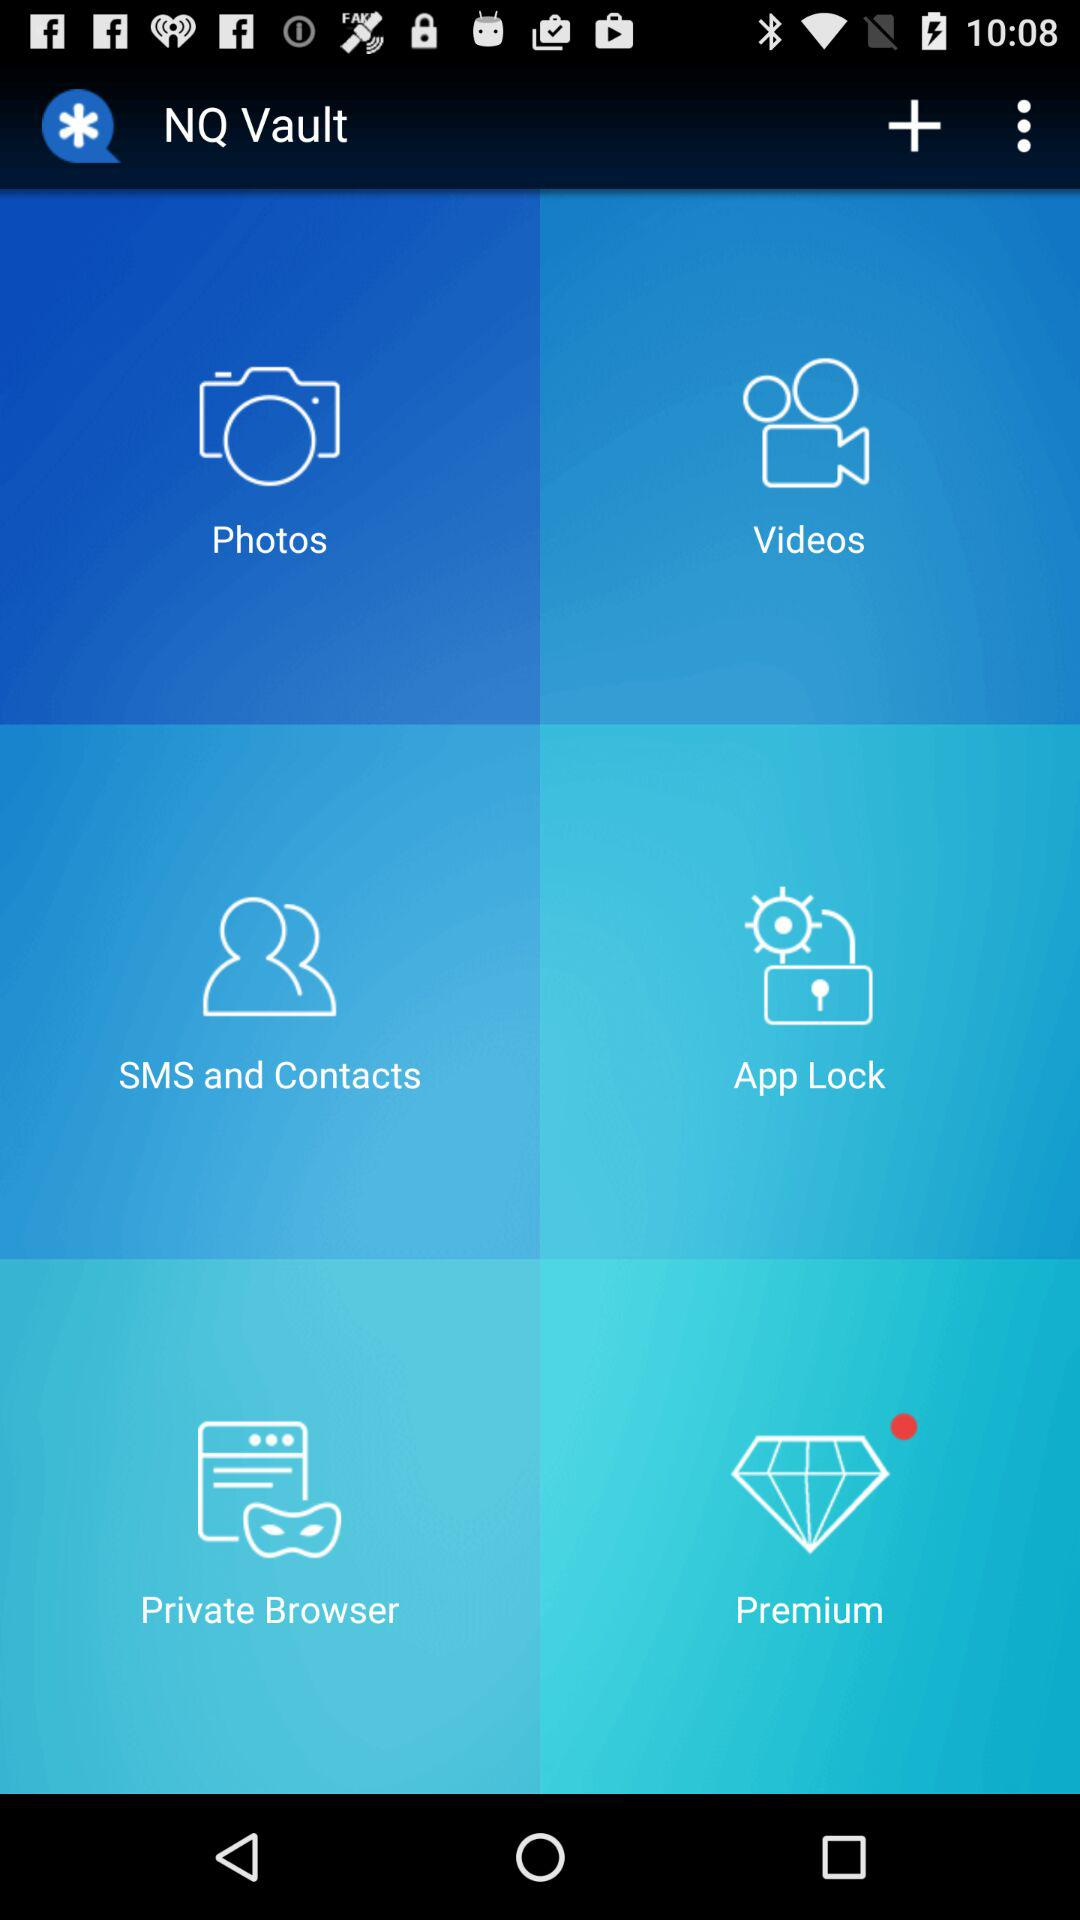What is the name of the application? The name of the application is "NQ Vault". 